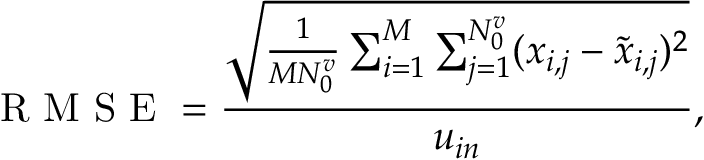<formula> <loc_0><loc_0><loc_500><loc_500>R M S E = \frac { \sqrt { \frac { 1 } { M N _ { 0 } ^ { v } } \sum _ { i = 1 } ^ { M } \sum _ { j = 1 } ^ { N _ { 0 } ^ { v } } ( x _ { i , j } - \widetilde { x } _ { i , j } ) ^ { 2 } } } { u _ { i n } } ,</formula> 